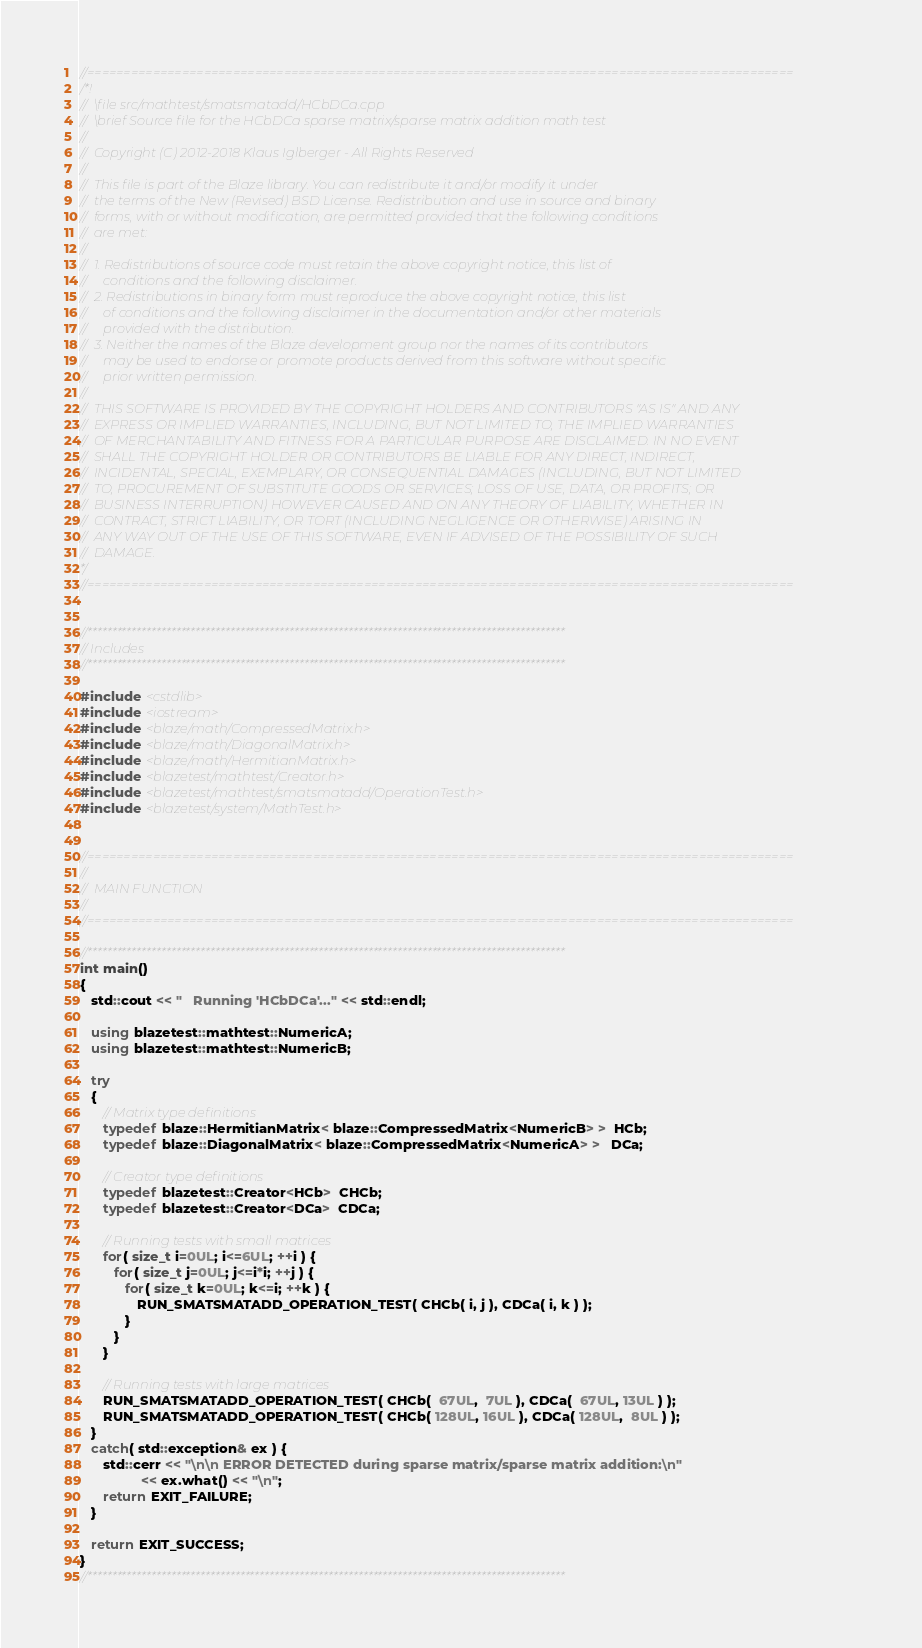Convert code to text. <code><loc_0><loc_0><loc_500><loc_500><_C++_>//=================================================================================================
/*!
//  \file src/mathtest/smatsmatadd/HCbDCa.cpp
//  \brief Source file for the HCbDCa sparse matrix/sparse matrix addition math test
//
//  Copyright (C) 2012-2018 Klaus Iglberger - All Rights Reserved
//
//  This file is part of the Blaze library. You can redistribute it and/or modify it under
//  the terms of the New (Revised) BSD License. Redistribution and use in source and binary
//  forms, with or without modification, are permitted provided that the following conditions
//  are met:
//
//  1. Redistributions of source code must retain the above copyright notice, this list of
//     conditions and the following disclaimer.
//  2. Redistributions in binary form must reproduce the above copyright notice, this list
//     of conditions and the following disclaimer in the documentation and/or other materials
//     provided with the distribution.
//  3. Neither the names of the Blaze development group nor the names of its contributors
//     may be used to endorse or promote products derived from this software without specific
//     prior written permission.
//
//  THIS SOFTWARE IS PROVIDED BY THE COPYRIGHT HOLDERS AND CONTRIBUTORS "AS IS" AND ANY
//  EXPRESS OR IMPLIED WARRANTIES, INCLUDING, BUT NOT LIMITED TO, THE IMPLIED WARRANTIES
//  OF MERCHANTABILITY AND FITNESS FOR A PARTICULAR PURPOSE ARE DISCLAIMED. IN NO EVENT
//  SHALL THE COPYRIGHT HOLDER OR CONTRIBUTORS BE LIABLE FOR ANY DIRECT, INDIRECT,
//  INCIDENTAL, SPECIAL, EXEMPLARY, OR CONSEQUENTIAL DAMAGES (INCLUDING, BUT NOT LIMITED
//  TO, PROCUREMENT OF SUBSTITUTE GOODS OR SERVICES; LOSS OF USE, DATA, OR PROFITS; OR
//  BUSINESS INTERRUPTION) HOWEVER CAUSED AND ON ANY THEORY OF LIABILITY, WHETHER IN
//  CONTRACT, STRICT LIABILITY, OR TORT (INCLUDING NEGLIGENCE OR OTHERWISE) ARISING IN
//  ANY WAY OUT OF THE USE OF THIS SOFTWARE, EVEN IF ADVISED OF THE POSSIBILITY OF SUCH
//  DAMAGE.
*/
//=================================================================================================


//*************************************************************************************************
// Includes
//*************************************************************************************************

#include <cstdlib>
#include <iostream>
#include <blaze/math/CompressedMatrix.h>
#include <blaze/math/DiagonalMatrix.h>
#include <blaze/math/HermitianMatrix.h>
#include <blazetest/mathtest/Creator.h>
#include <blazetest/mathtest/smatsmatadd/OperationTest.h>
#include <blazetest/system/MathTest.h>


//=================================================================================================
//
//  MAIN FUNCTION
//
//=================================================================================================

//*************************************************************************************************
int main()
{
   std::cout << "   Running 'HCbDCa'..." << std::endl;

   using blazetest::mathtest::NumericA;
   using blazetest::mathtest::NumericB;

   try
   {
      // Matrix type definitions
      typedef blaze::HermitianMatrix< blaze::CompressedMatrix<NumericB> >  HCb;
      typedef blaze::DiagonalMatrix< blaze::CompressedMatrix<NumericA> >   DCa;

      // Creator type definitions
      typedef blazetest::Creator<HCb>  CHCb;
      typedef blazetest::Creator<DCa>  CDCa;

      // Running tests with small matrices
      for( size_t i=0UL; i<=6UL; ++i ) {
         for( size_t j=0UL; j<=i*i; ++j ) {
            for( size_t k=0UL; k<=i; ++k ) {
               RUN_SMATSMATADD_OPERATION_TEST( CHCb( i, j ), CDCa( i, k ) );
            }
         }
      }

      // Running tests with large matrices
      RUN_SMATSMATADD_OPERATION_TEST( CHCb(  67UL,  7UL ), CDCa(  67UL, 13UL ) );
      RUN_SMATSMATADD_OPERATION_TEST( CHCb( 128UL, 16UL ), CDCa( 128UL,  8UL ) );
   }
   catch( std::exception& ex ) {
      std::cerr << "\n\n ERROR DETECTED during sparse matrix/sparse matrix addition:\n"
                << ex.what() << "\n";
      return EXIT_FAILURE;
   }

   return EXIT_SUCCESS;
}
//*************************************************************************************************
</code> 